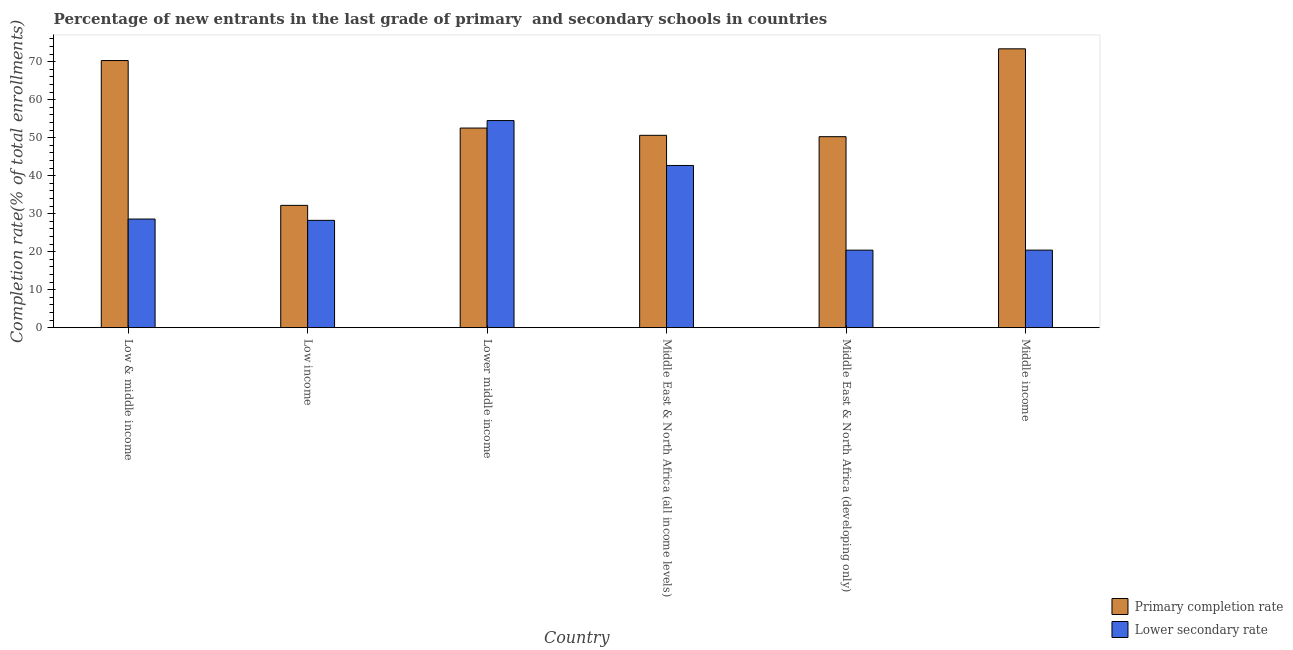How many different coloured bars are there?
Your answer should be very brief. 2. How many groups of bars are there?
Your answer should be compact. 6. Are the number of bars on each tick of the X-axis equal?
Make the answer very short. Yes. How many bars are there on the 2nd tick from the left?
Ensure brevity in your answer.  2. What is the label of the 5th group of bars from the left?
Offer a terse response. Middle East & North Africa (developing only). What is the completion rate in secondary schools in Low income?
Offer a terse response. 28.24. Across all countries, what is the maximum completion rate in primary schools?
Keep it short and to the point. 73.38. Across all countries, what is the minimum completion rate in primary schools?
Make the answer very short. 32.18. In which country was the completion rate in secondary schools maximum?
Make the answer very short. Lower middle income. In which country was the completion rate in primary schools minimum?
Offer a terse response. Low income. What is the total completion rate in secondary schools in the graph?
Make the answer very short. 194.83. What is the difference between the completion rate in secondary schools in Low income and that in Lower middle income?
Your answer should be compact. -26.26. What is the difference between the completion rate in secondary schools in Low income and the completion rate in primary schools in Middle East & North Africa (all income levels)?
Ensure brevity in your answer.  -22.37. What is the average completion rate in primary schools per country?
Ensure brevity in your answer.  54.88. What is the difference between the completion rate in secondary schools and completion rate in primary schools in Middle East & North Africa (all income levels)?
Your response must be concise. -7.93. What is the ratio of the completion rate in primary schools in Low & middle income to that in Middle income?
Provide a short and direct response. 0.96. Is the completion rate in secondary schools in Lower middle income less than that in Middle East & North Africa (all income levels)?
Your response must be concise. No. What is the difference between the highest and the second highest completion rate in secondary schools?
Your response must be concise. 11.82. What is the difference between the highest and the lowest completion rate in primary schools?
Offer a terse response. 41.2. In how many countries, is the completion rate in secondary schools greater than the average completion rate in secondary schools taken over all countries?
Provide a short and direct response. 2. What does the 1st bar from the left in Middle East & North Africa (developing only) represents?
Ensure brevity in your answer.  Primary completion rate. What does the 2nd bar from the right in Middle East & North Africa (developing only) represents?
Provide a succinct answer. Primary completion rate. Are all the bars in the graph horizontal?
Provide a short and direct response. No. How many countries are there in the graph?
Keep it short and to the point. 6. Are the values on the major ticks of Y-axis written in scientific E-notation?
Your answer should be very brief. No. Where does the legend appear in the graph?
Offer a very short reply. Bottom right. What is the title of the graph?
Provide a short and direct response. Percentage of new entrants in the last grade of primary  and secondary schools in countries. Does "Official creditors" appear as one of the legend labels in the graph?
Ensure brevity in your answer.  No. What is the label or title of the Y-axis?
Make the answer very short. Completion rate(% of total enrollments). What is the Completion rate(% of total enrollments) in Primary completion rate in Low & middle income?
Your answer should be compact. 70.3. What is the Completion rate(% of total enrollments) in Lower secondary rate in Low & middle income?
Ensure brevity in your answer.  28.59. What is the Completion rate(% of total enrollments) of Primary completion rate in Low income?
Your answer should be very brief. 32.18. What is the Completion rate(% of total enrollments) in Lower secondary rate in Low income?
Offer a very short reply. 28.24. What is the Completion rate(% of total enrollments) in Primary completion rate in Lower middle income?
Your response must be concise. 52.53. What is the Completion rate(% of total enrollments) of Lower secondary rate in Lower middle income?
Provide a succinct answer. 54.5. What is the Completion rate(% of total enrollments) in Primary completion rate in Middle East & North Africa (all income levels)?
Make the answer very short. 50.62. What is the Completion rate(% of total enrollments) of Lower secondary rate in Middle East & North Africa (all income levels)?
Provide a short and direct response. 42.69. What is the Completion rate(% of total enrollments) of Primary completion rate in Middle East & North Africa (developing only)?
Your answer should be compact. 50.26. What is the Completion rate(% of total enrollments) of Lower secondary rate in Middle East & North Africa (developing only)?
Your answer should be very brief. 20.4. What is the Completion rate(% of total enrollments) in Primary completion rate in Middle income?
Your response must be concise. 73.38. What is the Completion rate(% of total enrollments) of Lower secondary rate in Middle income?
Offer a terse response. 20.41. Across all countries, what is the maximum Completion rate(% of total enrollments) of Primary completion rate?
Make the answer very short. 73.38. Across all countries, what is the maximum Completion rate(% of total enrollments) of Lower secondary rate?
Give a very brief answer. 54.5. Across all countries, what is the minimum Completion rate(% of total enrollments) of Primary completion rate?
Ensure brevity in your answer.  32.18. Across all countries, what is the minimum Completion rate(% of total enrollments) of Lower secondary rate?
Offer a terse response. 20.4. What is the total Completion rate(% of total enrollments) in Primary completion rate in the graph?
Your answer should be compact. 329.27. What is the total Completion rate(% of total enrollments) in Lower secondary rate in the graph?
Your answer should be compact. 194.83. What is the difference between the Completion rate(% of total enrollments) in Primary completion rate in Low & middle income and that in Low income?
Provide a succinct answer. 38.12. What is the difference between the Completion rate(% of total enrollments) in Lower secondary rate in Low & middle income and that in Low income?
Provide a succinct answer. 0.34. What is the difference between the Completion rate(% of total enrollments) in Primary completion rate in Low & middle income and that in Lower middle income?
Your answer should be very brief. 17.77. What is the difference between the Completion rate(% of total enrollments) of Lower secondary rate in Low & middle income and that in Lower middle income?
Keep it short and to the point. -25.91. What is the difference between the Completion rate(% of total enrollments) of Primary completion rate in Low & middle income and that in Middle East & North Africa (all income levels)?
Give a very brief answer. 19.68. What is the difference between the Completion rate(% of total enrollments) in Lower secondary rate in Low & middle income and that in Middle East & North Africa (all income levels)?
Offer a terse response. -14.1. What is the difference between the Completion rate(% of total enrollments) in Primary completion rate in Low & middle income and that in Middle East & North Africa (developing only)?
Provide a succinct answer. 20.04. What is the difference between the Completion rate(% of total enrollments) in Lower secondary rate in Low & middle income and that in Middle East & North Africa (developing only)?
Offer a terse response. 8.19. What is the difference between the Completion rate(% of total enrollments) of Primary completion rate in Low & middle income and that in Middle income?
Ensure brevity in your answer.  -3.09. What is the difference between the Completion rate(% of total enrollments) of Lower secondary rate in Low & middle income and that in Middle income?
Give a very brief answer. 8.18. What is the difference between the Completion rate(% of total enrollments) in Primary completion rate in Low income and that in Lower middle income?
Your answer should be compact. -20.35. What is the difference between the Completion rate(% of total enrollments) of Lower secondary rate in Low income and that in Lower middle income?
Keep it short and to the point. -26.26. What is the difference between the Completion rate(% of total enrollments) in Primary completion rate in Low income and that in Middle East & North Africa (all income levels)?
Provide a succinct answer. -18.43. What is the difference between the Completion rate(% of total enrollments) in Lower secondary rate in Low income and that in Middle East & North Africa (all income levels)?
Offer a terse response. -14.44. What is the difference between the Completion rate(% of total enrollments) in Primary completion rate in Low income and that in Middle East & North Africa (developing only)?
Offer a very short reply. -18.08. What is the difference between the Completion rate(% of total enrollments) of Lower secondary rate in Low income and that in Middle East & North Africa (developing only)?
Keep it short and to the point. 7.84. What is the difference between the Completion rate(% of total enrollments) in Primary completion rate in Low income and that in Middle income?
Provide a short and direct response. -41.2. What is the difference between the Completion rate(% of total enrollments) in Lower secondary rate in Low income and that in Middle income?
Keep it short and to the point. 7.84. What is the difference between the Completion rate(% of total enrollments) in Primary completion rate in Lower middle income and that in Middle East & North Africa (all income levels)?
Your answer should be compact. 1.91. What is the difference between the Completion rate(% of total enrollments) of Lower secondary rate in Lower middle income and that in Middle East & North Africa (all income levels)?
Your response must be concise. 11.82. What is the difference between the Completion rate(% of total enrollments) in Primary completion rate in Lower middle income and that in Middle East & North Africa (developing only)?
Offer a very short reply. 2.27. What is the difference between the Completion rate(% of total enrollments) of Lower secondary rate in Lower middle income and that in Middle East & North Africa (developing only)?
Provide a succinct answer. 34.1. What is the difference between the Completion rate(% of total enrollments) of Primary completion rate in Lower middle income and that in Middle income?
Ensure brevity in your answer.  -20.85. What is the difference between the Completion rate(% of total enrollments) of Lower secondary rate in Lower middle income and that in Middle income?
Provide a succinct answer. 34.1. What is the difference between the Completion rate(% of total enrollments) of Primary completion rate in Middle East & North Africa (all income levels) and that in Middle East & North Africa (developing only)?
Provide a succinct answer. 0.36. What is the difference between the Completion rate(% of total enrollments) in Lower secondary rate in Middle East & North Africa (all income levels) and that in Middle East & North Africa (developing only)?
Your response must be concise. 22.28. What is the difference between the Completion rate(% of total enrollments) of Primary completion rate in Middle East & North Africa (all income levels) and that in Middle income?
Offer a terse response. -22.77. What is the difference between the Completion rate(% of total enrollments) of Lower secondary rate in Middle East & North Africa (all income levels) and that in Middle income?
Provide a short and direct response. 22.28. What is the difference between the Completion rate(% of total enrollments) in Primary completion rate in Middle East & North Africa (developing only) and that in Middle income?
Your response must be concise. -23.12. What is the difference between the Completion rate(% of total enrollments) in Lower secondary rate in Middle East & North Africa (developing only) and that in Middle income?
Offer a very short reply. -0.01. What is the difference between the Completion rate(% of total enrollments) in Primary completion rate in Low & middle income and the Completion rate(% of total enrollments) in Lower secondary rate in Low income?
Ensure brevity in your answer.  42.05. What is the difference between the Completion rate(% of total enrollments) of Primary completion rate in Low & middle income and the Completion rate(% of total enrollments) of Lower secondary rate in Lower middle income?
Offer a very short reply. 15.8. What is the difference between the Completion rate(% of total enrollments) in Primary completion rate in Low & middle income and the Completion rate(% of total enrollments) in Lower secondary rate in Middle East & North Africa (all income levels)?
Your response must be concise. 27.61. What is the difference between the Completion rate(% of total enrollments) of Primary completion rate in Low & middle income and the Completion rate(% of total enrollments) of Lower secondary rate in Middle East & North Africa (developing only)?
Give a very brief answer. 49.9. What is the difference between the Completion rate(% of total enrollments) in Primary completion rate in Low & middle income and the Completion rate(% of total enrollments) in Lower secondary rate in Middle income?
Make the answer very short. 49.89. What is the difference between the Completion rate(% of total enrollments) of Primary completion rate in Low income and the Completion rate(% of total enrollments) of Lower secondary rate in Lower middle income?
Offer a very short reply. -22.32. What is the difference between the Completion rate(% of total enrollments) in Primary completion rate in Low income and the Completion rate(% of total enrollments) in Lower secondary rate in Middle East & North Africa (all income levels)?
Your answer should be compact. -10.5. What is the difference between the Completion rate(% of total enrollments) of Primary completion rate in Low income and the Completion rate(% of total enrollments) of Lower secondary rate in Middle East & North Africa (developing only)?
Offer a terse response. 11.78. What is the difference between the Completion rate(% of total enrollments) of Primary completion rate in Low income and the Completion rate(% of total enrollments) of Lower secondary rate in Middle income?
Offer a terse response. 11.78. What is the difference between the Completion rate(% of total enrollments) in Primary completion rate in Lower middle income and the Completion rate(% of total enrollments) in Lower secondary rate in Middle East & North Africa (all income levels)?
Your answer should be compact. 9.85. What is the difference between the Completion rate(% of total enrollments) of Primary completion rate in Lower middle income and the Completion rate(% of total enrollments) of Lower secondary rate in Middle East & North Africa (developing only)?
Provide a succinct answer. 32.13. What is the difference between the Completion rate(% of total enrollments) in Primary completion rate in Lower middle income and the Completion rate(% of total enrollments) in Lower secondary rate in Middle income?
Make the answer very short. 32.13. What is the difference between the Completion rate(% of total enrollments) in Primary completion rate in Middle East & North Africa (all income levels) and the Completion rate(% of total enrollments) in Lower secondary rate in Middle East & North Africa (developing only)?
Provide a succinct answer. 30.22. What is the difference between the Completion rate(% of total enrollments) in Primary completion rate in Middle East & North Africa (all income levels) and the Completion rate(% of total enrollments) in Lower secondary rate in Middle income?
Keep it short and to the point. 30.21. What is the difference between the Completion rate(% of total enrollments) of Primary completion rate in Middle East & North Africa (developing only) and the Completion rate(% of total enrollments) of Lower secondary rate in Middle income?
Offer a terse response. 29.85. What is the average Completion rate(% of total enrollments) in Primary completion rate per country?
Keep it short and to the point. 54.88. What is the average Completion rate(% of total enrollments) in Lower secondary rate per country?
Give a very brief answer. 32.47. What is the difference between the Completion rate(% of total enrollments) in Primary completion rate and Completion rate(% of total enrollments) in Lower secondary rate in Low & middle income?
Ensure brevity in your answer.  41.71. What is the difference between the Completion rate(% of total enrollments) of Primary completion rate and Completion rate(% of total enrollments) of Lower secondary rate in Low income?
Provide a short and direct response. 3.94. What is the difference between the Completion rate(% of total enrollments) of Primary completion rate and Completion rate(% of total enrollments) of Lower secondary rate in Lower middle income?
Ensure brevity in your answer.  -1.97. What is the difference between the Completion rate(% of total enrollments) in Primary completion rate and Completion rate(% of total enrollments) in Lower secondary rate in Middle East & North Africa (all income levels)?
Your response must be concise. 7.93. What is the difference between the Completion rate(% of total enrollments) of Primary completion rate and Completion rate(% of total enrollments) of Lower secondary rate in Middle East & North Africa (developing only)?
Make the answer very short. 29.86. What is the difference between the Completion rate(% of total enrollments) in Primary completion rate and Completion rate(% of total enrollments) in Lower secondary rate in Middle income?
Your answer should be very brief. 52.98. What is the ratio of the Completion rate(% of total enrollments) of Primary completion rate in Low & middle income to that in Low income?
Provide a succinct answer. 2.18. What is the ratio of the Completion rate(% of total enrollments) in Lower secondary rate in Low & middle income to that in Low income?
Make the answer very short. 1.01. What is the ratio of the Completion rate(% of total enrollments) in Primary completion rate in Low & middle income to that in Lower middle income?
Provide a short and direct response. 1.34. What is the ratio of the Completion rate(% of total enrollments) of Lower secondary rate in Low & middle income to that in Lower middle income?
Your answer should be compact. 0.52. What is the ratio of the Completion rate(% of total enrollments) in Primary completion rate in Low & middle income to that in Middle East & North Africa (all income levels)?
Offer a very short reply. 1.39. What is the ratio of the Completion rate(% of total enrollments) in Lower secondary rate in Low & middle income to that in Middle East & North Africa (all income levels)?
Give a very brief answer. 0.67. What is the ratio of the Completion rate(% of total enrollments) of Primary completion rate in Low & middle income to that in Middle East & North Africa (developing only)?
Your answer should be very brief. 1.4. What is the ratio of the Completion rate(% of total enrollments) of Lower secondary rate in Low & middle income to that in Middle East & North Africa (developing only)?
Ensure brevity in your answer.  1.4. What is the ratio of the Completion rate(% of total enrollments) in Primary completion rate in Low & middle income to that in Middle income?
Your answer should be compact. 0.96. What is the ratio of the Completion rate(% of total enrollments) in Lower secondary rate in Low & middle income to that in Middle income?
Ensure brevity in your answer.  1.4. What is the ratio of the Completion rate(% of total enrollments) of Primary completion rate in Low income to that in Lower middle income?
Your answer should be very brief. 0.61. What is the ratio of the Completion rate(% of total enrollments) in Lower secondary rate in Low income to that in Lower middle income?
Give a very brief answer. 0.52. What is the ratio of the Completion rate(% of total enrollments) in Primary completion rate in Low income to that in Middle East & North Africa (all income levels)?
Your answer should be compact. 0.64. What is the ratio of the Completion rate(% of total enrollments) of Lower secondary rate in Low income to that in Middle East & North Africa (all income levels)?
Provide a short and direct response. 0.66. What is the ratio of the Completion rate(% of total enrollments) of Primary completion rate in Low income to that in Middle East & North Africa (developing only)?
Keep it short and to the point. 0.64. What is the ratio of the Completion rate(% of total enrollments) in Lower secondary rate in Low income to that in Middle East & North Africa (developing only)?
Your response must be concise. 1.38. What is the ratio of the Completion rate(% of total enrollments) of Primary completion rate in Low income to that in Middle income?
Ensure brevity in your answer.  0.44. What is the ratio of the Completion rate(% of total enrollments) of Lower secondary rate in Low income to that in Middle income?
Your answer should be compact. 1.38. What is the ratio of the Completion rate(% of total enrollments) of Primary completion rate in Lower middle income to that in Middle East & North Africa (all income levels)?
Your answer should be compact. 1.04. What is the ratio of the Completion rate(% of total enrollments) of Lower secondary rate in Lower middle income to that in Middle East & North Africa (all income levels)?
Provide a succinct answer. 1.28. What is the ratio of the Completion rate(% of total enrollments) of Primary completion rate in Lower middle income to that in Middle East & North Africa (developing only)?
Your response must be concise. 1.05. What is the ratio of the Completion rate(% of total enrollments) of Lower secondary rate in Lower middle income to that in Middle East & North Africa (developing only)?
Offer a terse response. 2.67. What is the ratio of the Completion rate(% of total enrollments) of Primary completion rate in Lower middle income to that in Middle income?
Make the answer very short. 0.72. What is the ratio of the Completion rate(% of total enrollments) in Lower secondary rate in Lower middle income to that in Middle income?
Offer a very short reply. 2.67. What is the ratio of the Completion rate(% of total enrollments) in Primary completion rate in Middle East & North Africa (all income levels) to that in Middle East & North Africa (developing only)?
Offer a terse response. 1.01. What is the ratio of the Completion rate(% of total enrollments) of Lower secondary rate in Middle East & North Africa (all income levels) to that in Middle East & North Africa (developing only)?
Your response must be concise. 2.09. What is the ratio of the Completion rate(% of total enrollments) in Primary completion rate in Middle East & North Africa (all income levels) to that in Middle income?
Make the answer very short. 0.69. What is the ratio of the Completion rate(% of total enrollments) of Lower secondary rate in Middle East & North Africa (all income levels) to that in Middle income?
Offer a terse response. 2.09. What is the ratio of the Completion rate(% of total enrollments) in Primary completion rate in Middle East & North Africa (developing only) to that in Middle income?
Ensure brevity in your answer.  0.68. What is the difference between the highest and the second highest Completion rate(% of total enrollments) in Primary completion rate?
Keep it short and to the point. 3.09. What is the difference between the highest and the second highest Completion rate(% of total enrollments) in Lower secondary rate?
Ensure brevity in your answer.  11.82. What is the difference between the highest and the lowest Completion rate(% of total enrollments) of Primary completion rate?
Your answer should be very brief. 41.2. What is the difference between the highest and the lowest Completion rate(% of total enrollments) of Lower secondary rate?
Provide a succinct answer. 34.1. 